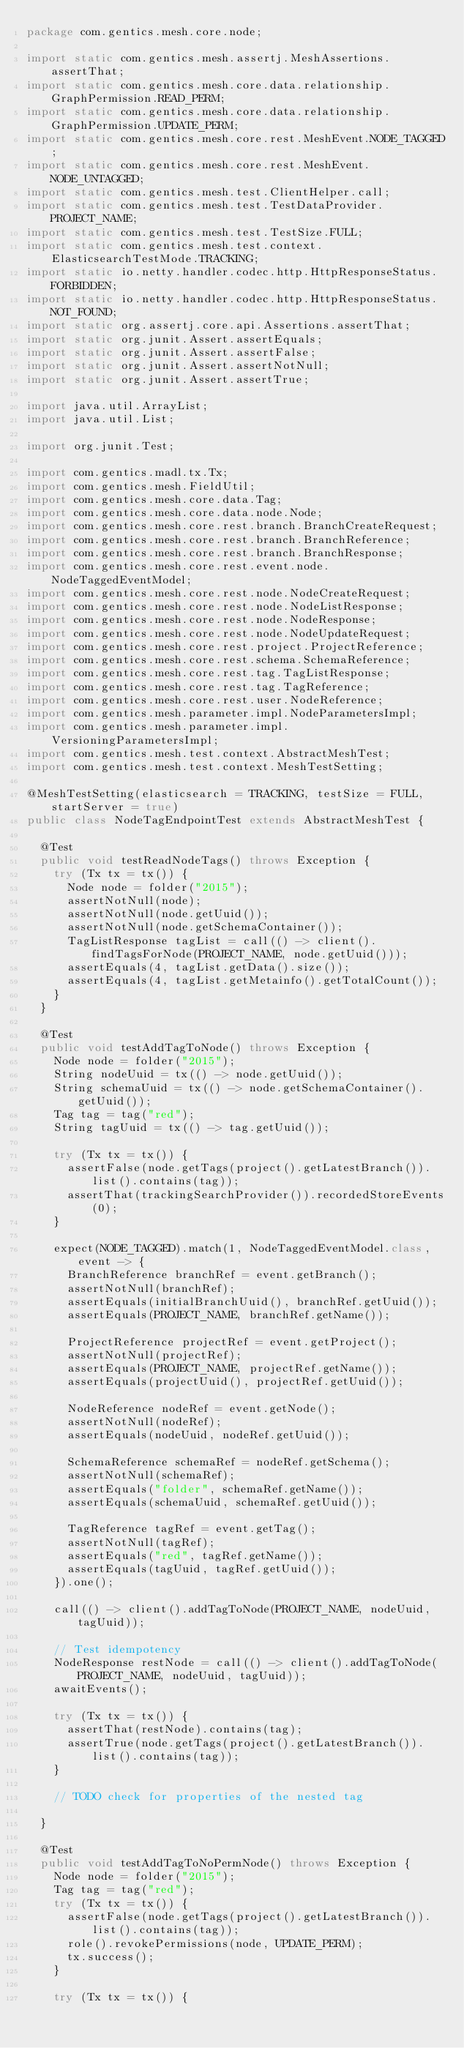Convert code to text. <code><loc_0><loc_0><loc_500><loc_500><_Java_>package com.gentics.mesh.core.node;

import static com.gentics.mesh.assertj.MeshAssertions.assertThat;
import static com.gentics.mesh.core.data.relationship.GraphPermission.READ_PERM;
import static com.gentics.mesh.core.data.relationship.GraphPermission.UPDATE_PERM;
import static com.gentics.mesh.core.rest.MeshEvent.NODE_TAGGED;
import static com.gentics.mesh.core.rest.MeshEvent.NODE_UNTAGGED;
import static com.gentics.mesh.test.ClientHelper.call;
import static com.gentics.mesh.test.TestDataProvider.PROJECT_NAME;
import static com.gentics.mesh.test.TestSize.FULL;
import static com.gentics.mesh.test.context.ElasticsearchTestMode.TRACKING;
import static io.netty.handler.codec.http.HttpResponseStatus.FORBIDDEN;
import static io.netty.handler.codec.http.HttpResponseStatus.NOT_FOUND;
import static org.assertj.core.api.Assertions.assertThat;
import static org.junit.Assert.assertEquals;
import static org.junit.Assert.assertFalse;
import static org.junit.Assert.assertNotNull;
import static org.junit.Assert.assertTrue;

import java.util.ArrayList;
import java.util.List;

import org.junit.Test;

import com.gentics.madl.tx.Tx;
import com.gentics.mesh.FieldUtil;
import com.gentics.mesh.core.data.Tag;
import com.gentics.mesh.core.data.node.Node;
import com.gentics.mesh.core.rest.branch.BranchCreateRequest;
import com.gentics.mesh.core.rest.branch.BranchReference;
import com.gentics.mesh.core.rest.branch.BranchResponse;
import com.gentics.mesh.core.rest.event.node.NodeTaggedEventModel;
import com.gentics.mesh.core.rest.node.NodeCreateRequest;
import com.gentics.mesh.core.rest.node.NodeListResponse;
import com.gentics.mesh.core.rest.node.NodeResponse;
import com.gentics.mesh.core.rest.node.NodeUpdateRequest;
import com.gentics.mesh.core.rest.project.ProjectReference;
import com.gentics.mesh.core.rest.schema.SchemaReference;
import com.gentics.mesh.core.rest.tag.TagListResponse;
import com.gentics.mesh.core.rest.tag.TagReference;
import com.gentics.mesh.core.rest.user.NodeReference;
import com.gentics.mesh.parameter.impl.NodeParametersImpl;
import com.gentics.mesh.parameter.impl.VersioningParametersImpl;
import com.gentics.mesh.test.context.AbstractMeshTest;
import com.gentics.mesh.test.context.MeshTestSetting;

@MeshTestSetting(elasticsearch = TRACKING, testSize = FULL, startServer = true)
public class NodeTagEndpointTest extends AbstractMeshTest {

	@Test
	public void testReadNodeTags() throws Exception {
		try (Tx tx = tx()) {
			Node node = folder("2015");
			assertNotNull(node);
			assertNotNull(node.getUuid());
			assertNotNull(node.getSchemaContainer());
			TagListResponse tagList = call(() -> client().findTagsForNode(PROJECT_NAME, node.getUuid()));
			assertEquals(4, tagList.getData().size());
			assertEquals(4, tagList.getMetainfo().getTotalCount());
		}
	}

	@Test
	public void testAddTagToNode() throws Exception {
		Node node = folder("2015");
		String nodeUuid = tx(() -> node.getUuid());
		String schemaUuid = tx(() -> node.getSchemaContainer().getUuid());
		Tag tag = tag("red");
		String tagUuid = tx(() -> tag.getUuid());

		try (Tx tx = tx()) {
			assertFalse(node.getTags(project().getLatestBranch()).list().contains(tag));
			assertThat(trackingSearchProvider()).recordedStoreEvents(0);
		}

		expect(NODE_TAGGED).match(1, NodeTaggedEventModel.class, event -> {
			BranchReference branchRef = event.getBranch();
			assertNotNull(branchRef);
			assertEquals(initialBranchUuid(), branchRef.getUuid());
			assertEquals(PROJECT_NAME, branchRef.getName());

			ProjectReference projectRef = event.getProject();
			assertNotNull(projectRef);
			assertEquals(PROJECT_NAME, projectRef.getName());
			assertEquals(projectUuid(), projectRef.getUuid());

			NodeReference nodeRef = event.getNode();
			assertNotNull(nodeRef);
			assertEquals(nodeUuid, nodeRef.getUuid());

			SchemaReference schemaRef = nodeRef.getSchema();
			assertNotNull(schemaRef);
			assertEquals("folder", schemaRef.getName());
			assertEquals(schemaUuid, schemaRef.getUuid());

			TagReference tagRef = event.getTag();
			assertNotNull(tagRef);
			assertEquals("red", tagRef.getName());
			assertEquals(tagUuid, tagRef.getUuid());
		}).one();

		call(() -> client().addTagToNode(PROJECT_NAME, nodeUuid, tagUuid));

		// Test idempotency
		NodeResponse restNode = call(() -> client().addTagToNode(PROJECT_NAME, nodeUuid, tagUuid));
		awaitEvents();

		try (Tx tx = tx()) {
			assertThat(restNode).contains(tag);
			assertTrue(node.getTags(project().getLatestBranch()).list().contains(tag));
		}

		// TODO check for properties of the nested tag

	}

	@Test
	public void testAddTagToNoPermNode() throws Exception {
		Node node = folder("2015");
		Tag tag = tag("red");
		try (Tx tx = tx()) {
			assertFalse(node.getTags(project().getLatestBranch()).list().contains(tag));
			role().revokePermissions(node, UPDATE_PERM);
			tx.success();
		}

		try (Tx tx = tx()) {</code> 